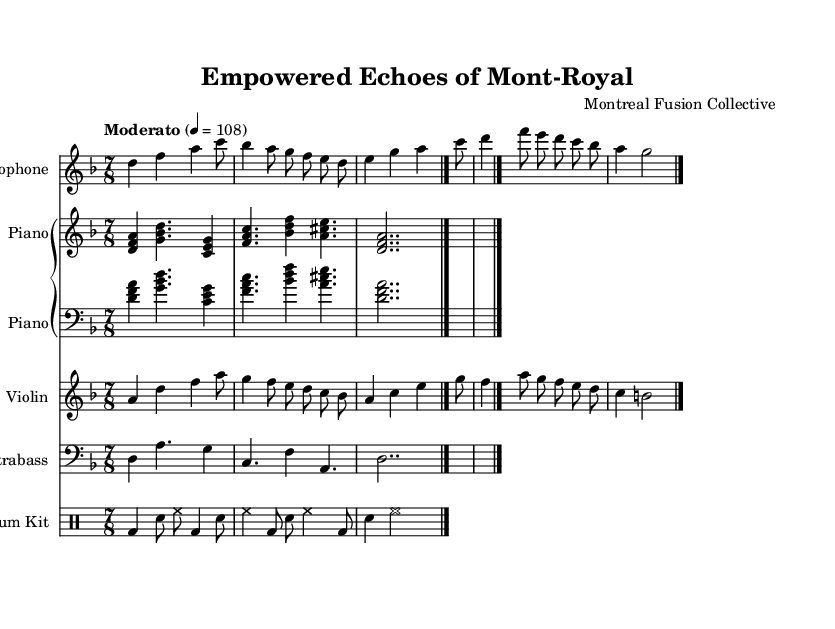What is the key signature of this music? The key signature can be found at the beginning of the music and is indicated by the symbols present. In this case, the key signature shows one flat, which corresponds to D minor.
Answer: D minor What is the time signature of this composition? The time signature is visible in the sheet music, specified in the upper left corner with the format of beats in a measure and the note value that represents one beat. Here, it is indicated as 7/8.
Answer: 7/8 What tempo marking is used for this piece? The tempo marking can be found written in the head section of the sheet music, indicating how fast the piece should be played. In this music, it states "Moderato" with a metronome marking of 108 beats per minute.
Answer: Moderato 4 = 108 How many different instruments are present in this score? The number of instruments can be determined by counting the distinct staves for each instrument listed in the score. There are five separate staves: Alto Saxophone, Piano, Violin, Contrabass, and Drum Kit.
Answer: Five What is the rhythmic pattern of the drum part? The drum part can be analyzed by looking at the notational values used in the drum staff. The pattern includes alternating bass drum and snare drum hits with a mixture of quarter and eighth notes, following a 7/8 time signature.
Answer: Mixed quarter and eighth notes Which theme does this composition primarily explore? The title "Empowered Echoes of Mont-Royal" suggests that the piece reflects themes of empowerment, particularly resonant in a fusion of jazz and classical elements, which may be aligned with a narrative of empowerment or representation.
Answer: Empowerment 